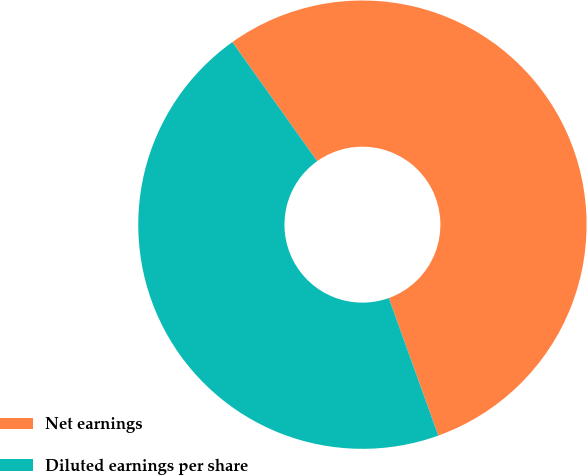Convert chart to OTSL. <chart><loc_0><loc_0><loc_500><loc_500><pie_chart><fcel>Net earnings<fcel>Diluted earnings per share<nl><fcel>54.36%<fcel>45.64%<nl></chart> 